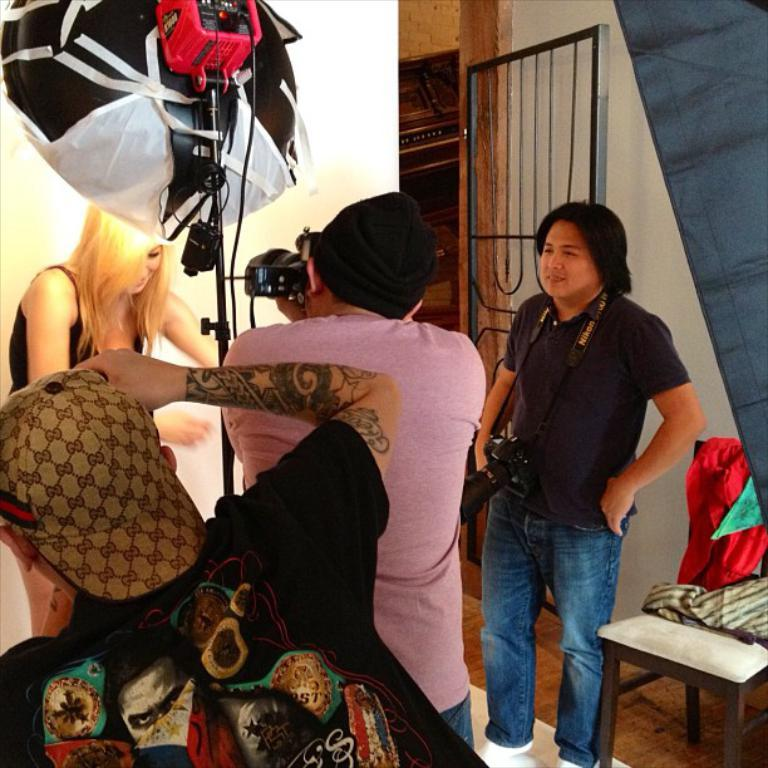What are the people in the image doing? The people in the image are standing. What are some of the people holding? Some of the people are holding cameras. Can you describe any other objects or features in the image? There is a light visible in the image. How many cracks can be seen on the light in the image? There are no cracks visible on the light in the image. What type of stitch is being used by the people in the image? The people in the image are not using any stitch; they are holding cameras. 